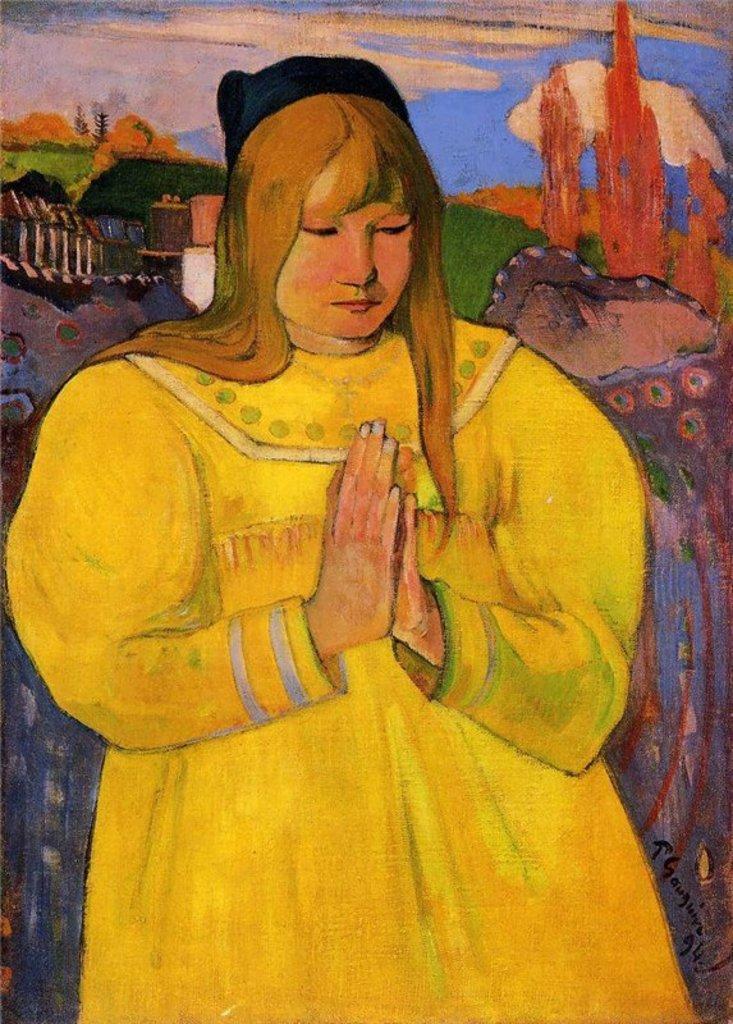Could you give a brief overview of what you see in this image? There is a painting in which, there is a person in yellow color dress praying and standing. In the background, there is grass on the ground, there are clouds in the sky and there are other objects. 